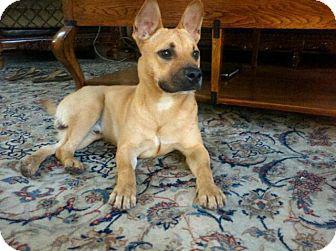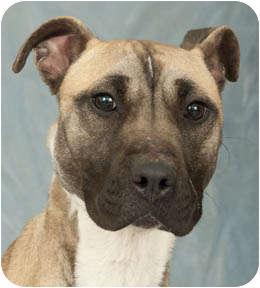The first image is the image on the left, the second image is the image on the right. Given the left and right images, does the statement "Left image contains one tan adult dog wearing a collar." hold true? Answer yes or no. No. 